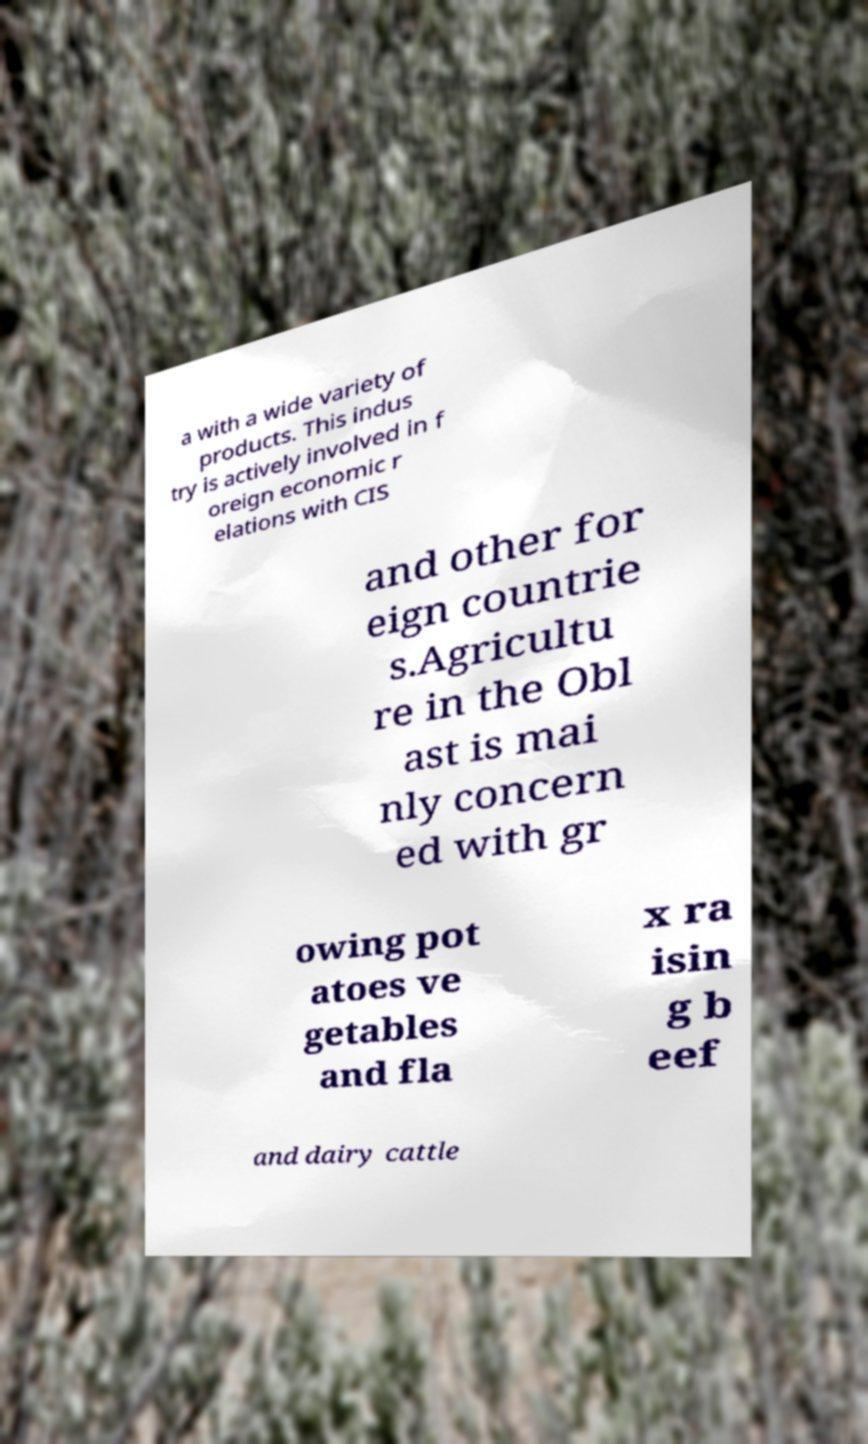Please identify and transcribe the text found in this image. a with a wide variety of products. This indus try is actively involved in f oreign economic r elations with CIS and other for eign countrie s.Agricultu re in the Obl ast is mai nly concern ed with gr owing pot atoes ve getables and fla x ra isin g b eef and dairy cattle 